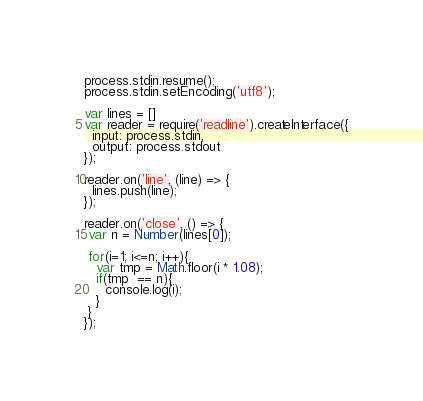<code> <loc_0><loc_0><loc_500><loc_500><_JavaScript_>process.stdin.resume();
process.stdin.setEncoding('utf8');

var lines = []
var reader = require('readline').createInterface({
  input: process.stdin,
  output: process.stdout
});

reader.on('line', (line) => {
  lines.push(line);
});

reader.on('close', () => {
 var n = Number(lines[0]);
 
 for(i=1; i<=n; i++){
   var tmp = Math.floor(i * 1.08);
   if(tmp  == n){
     console.log(i);
   }
 }
});</code> 